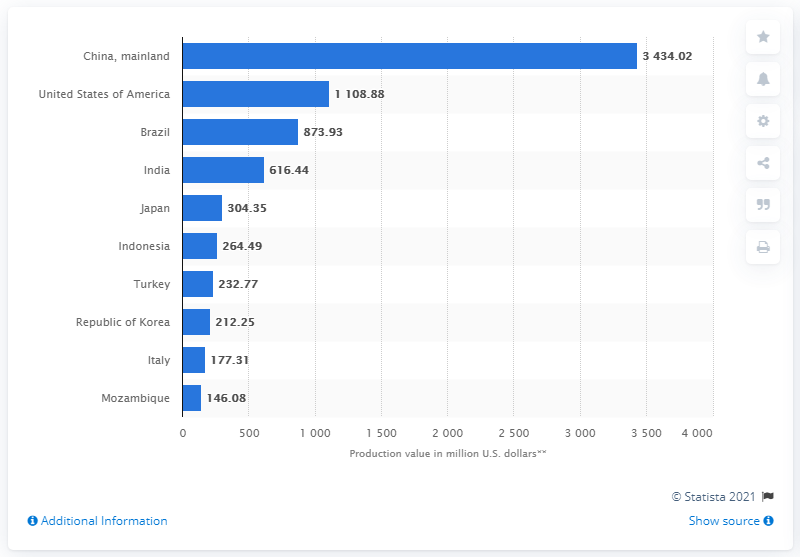Give some essential details in this illustration. In 2016, the value of China's tobacco industry was approximately 34,340.2 million US dollars. 